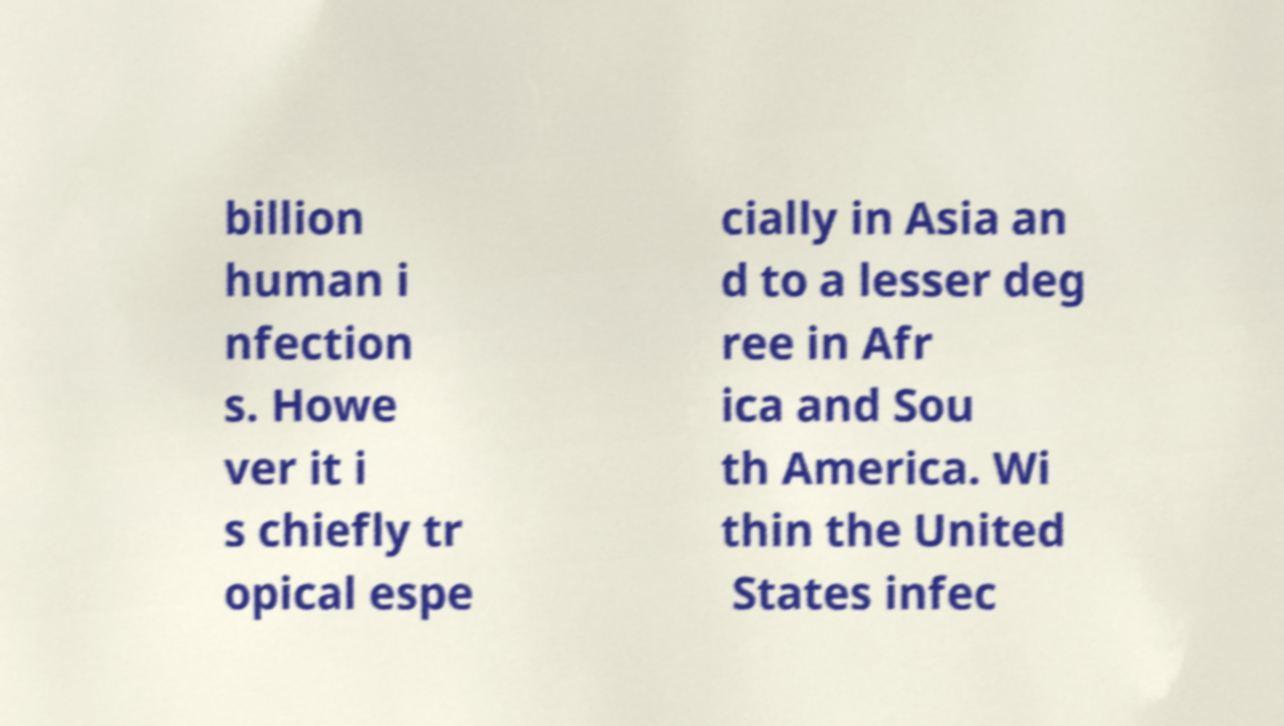Could you assist in decoding the text presented in this image and type it out clearly? billion human i nfection s. Howe ver it i s chiefly tr opical espe cially in Asia an d to a lesser deg ree in Afr ica and Sou th America. Wi thin the United States infec 